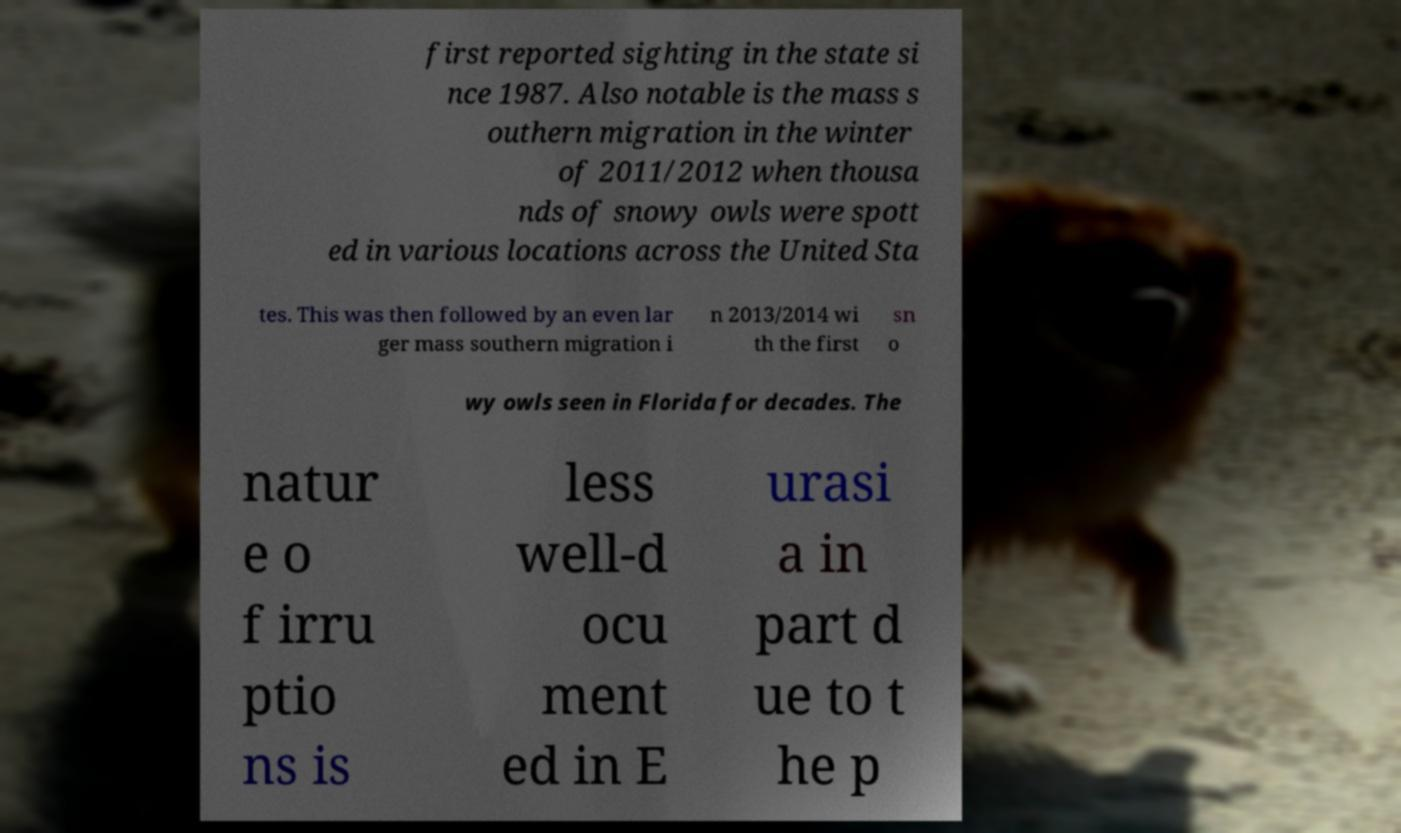There's text embedded in this image that I need extracted. Can you transcribe it verbatim? first reported sighting in the state si nce 1987. Also notable is the mass s outhern migration in the winter of 2011/2012 when thousa nds of snowy owls were spott ed in various locations across the United Sta tes. This was then followed by an even lar ger mass southern migration i n 2013/2014 wi th the first sn o wy owls seen in Florida for decades. The natur e o f irru ptio ns is less well-d ocu ment ed in E urasi a in part d ue to t he p 